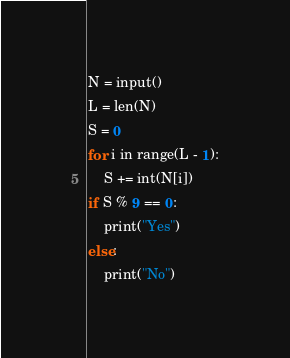Convert code to text. <code><loc_0><loc_0><loc_500><loc_500><_Python_>N = input()
L = len(N)
S = 0
for i in range(L - 1):
    S += int(N[i])
if S % 9 == 0:
    print("Yes")
else:
    print("No")</code> 